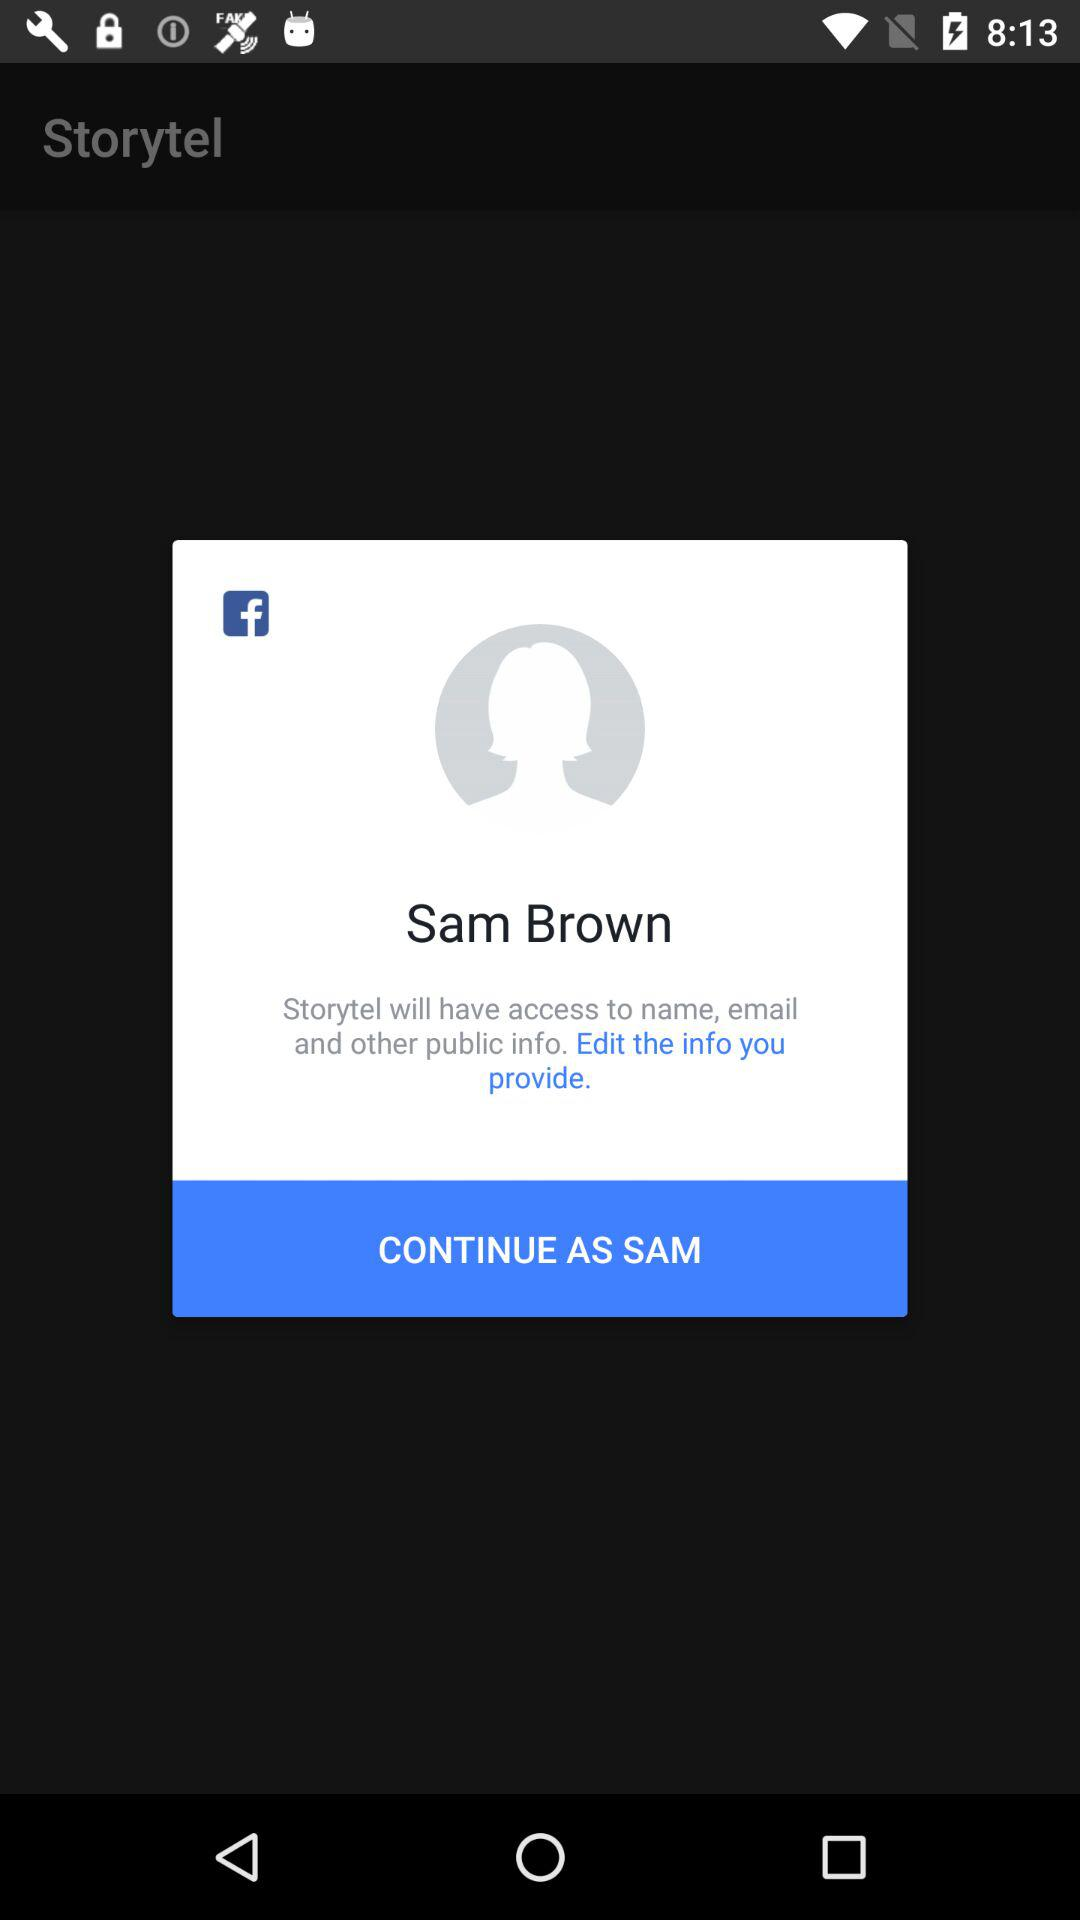What application is asking for permission? The application that is asking for permission is "Storytel". 